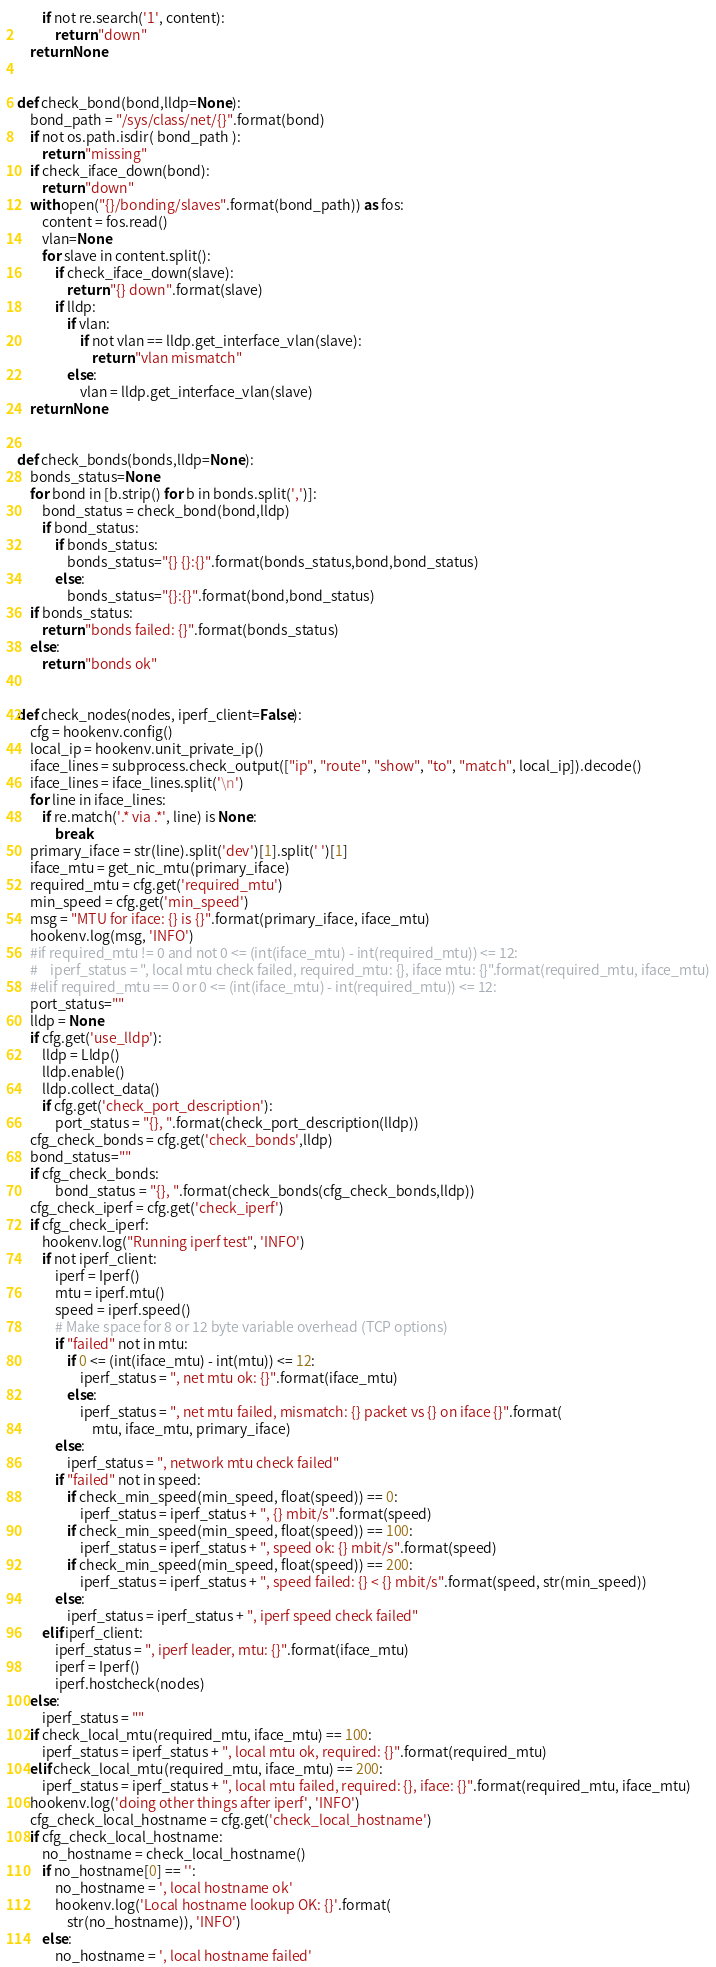Convert code to text. <code><loc_0><loc_0><loc_500><loc_500><_Python_>        if not re.search('1', content):
            return "down"
    return None


def check_bond(bond,lldp=None):
    bond_path = "/sys/class/net/{}".format(bond)
    if not os.path.isdir( bond_path ):
        return "missing"
    if check_iface_down(bond):
        return "down"
    with open("{}/bonding/slaves".format(bond_path)) as fos:
        content = fos.read()
        vlan=None
        for slave in content.split():
            if check_iface_down(slave):
                return "{} down".format(slave)
            if lldp:
                if vlan:
                    if not vlan == lldp.get_interface_vlan(slave):
                        return "vlan mismatch"
                else:
                    vlan = lldp.get_interface_vlan(slave)
    return None


def check_bonds(bonds,lldp=None):
    bonds_status=None
    for bond in [b.strip() for b in bonds.split(',')]:
        bond_status = check_bond(bond,lldp)
        if bond_status:
            if bonds_status:
                bonds_status="{} {}:{}".format(bonds_status,bond,bond_status)
            else:
                bonds_status="{}:{}".format(bond,bond_status)
    if bonds_status:
        return "bonds failed: {}".format(bonds_status)
    else:
        return "bonds ok"


def check_nodes(nodes, iperf_client=False):
    cfg = hookenv.config()
    local_ip = hookenv.unit_private_ip()
    iface_lines = subprocess.check_output(["ip", "route", "show", "to", "match", local_ip]).decode()
    iface_lines = iface_lines.split('\n')
    for line in iface_lines:
        if re.match('.* via .*', line) is None:
            break
    primary_iface = str(line).split('dev')[1].split(' ')[1]
    iface_mtu = get_nic_mtu(primary_iface)
    required_mtu = cfg.get('required_mtu')
    min_speed = cfg.get('min_speed')
    msg = "MTU for iface: {} is {}".format(primary_iface, iface_mtu)
    hookenv.log(msg, 'INFO')
    #if required_mtu != 0 and not 0 <= (int(iface_mtu) - int(required_mtu)) <= 12:
    #    iperf_status = ", local mtu check failed, required_mtu: {}, iface mtu: {}".format(required_mtu, iface_mtu)
    #elif required_mtu == 0 or 0 <= (int(iface_mtu) - int(required_mtu)) <= 12:
    port_status=""
    lldp = None
    if cfg.get('use_lldp'):
        lldp = Lldp()
        lldp.enable()
        lldp.collect_data()
        if cfg.get('check_port_description'):
            port_status = "{}, ".format(check_port_description(lldp))
    cfg_check_bonds = cfg.get('check_bonds',lldp)
    bond_status=""
    if cfg_check_bonds:
            bond_status = "{}, ".format(check_bonds(cfg_check_bonds,lldp))
    cfg_check_iperf = cfg.get('check_iperf')
    if cfg_check_iperf:
        hookenv.log("Running iperf test", 'INFO')
        if not iperf_client:
            iperf = Iperf()
            mtu = iperf.mtu()
            speed = iperf.speed()
            # Make space for 8 or 12 byte variable overhead (TCP options)
            if "failed" not in mtu:
                if 0 <= (int(iface_mtu) - int(mtu)) <= 12:
                    iperf_status = ", net mtu ok: {}".format(iface_mtu)
                else:
                    iperf_status = ", net mtu failed, mismatch: {} packet vs {} on iface {}".format(
                        mtu, iface_mtu, primary_iface)
            else:
                iperf_status = ", network mtu check failed"
            if "failed" not in speed:
                if check_min_speed(min_speed, float(speed)) == 0:
                    iperf_status = iperf_status + ", {} mbit/s".format(speed)
                if check_min_speed(min_speed, float(speed)) == 100:
                    iperf_status = iperf_status + ", speed ok: {} mbit/s".format(speed)
                if check_min_speed(min_speed, float(speed)) == 200:
                    iperf_status = iperf_status + ", speed failed: {} < {} mbit/s".format(speed, str(min_speed))
            else:
                iperf_status = iperf_status + ", iperf speed check failed"
        elif iperf_client:
            iperf_status = ", iperf leader, mtu: {}".format(iface_mtu)
            iperf = Iperf()
            iperf.hostcheck(nodes)
    else:
        iperf_status = ""
    if check_local_mtu(required_mtu, iface_mtu) == 100:
        iperf_status = iperf_status + ", local mtu ok, required: {}".format(required_mtu)
    elif check_local_mtu(required_mtu, iface_mtu) == 200:
        iperf_status = iperf_status + ", local mtu failed, required: {}, iface: {}".format(required_mtu, iface_mtu)
    hookenv.log('doing other things after iperf', 'INFO')
    cfg_check_local_hostname = cfg.get('check_local_hostname')
    if cfg_check_local_hostname:
        no_hostname = check_local_hostname()
        if no_hostname[0] == '':
            no_hostname = ', local hostname ok'
            hookenv.log('Local hostname lookup OK: {}'.format(
                str(no_hostname)), 'INFO')
        else:
            no_hostname = ', local hostname failed'</code> 